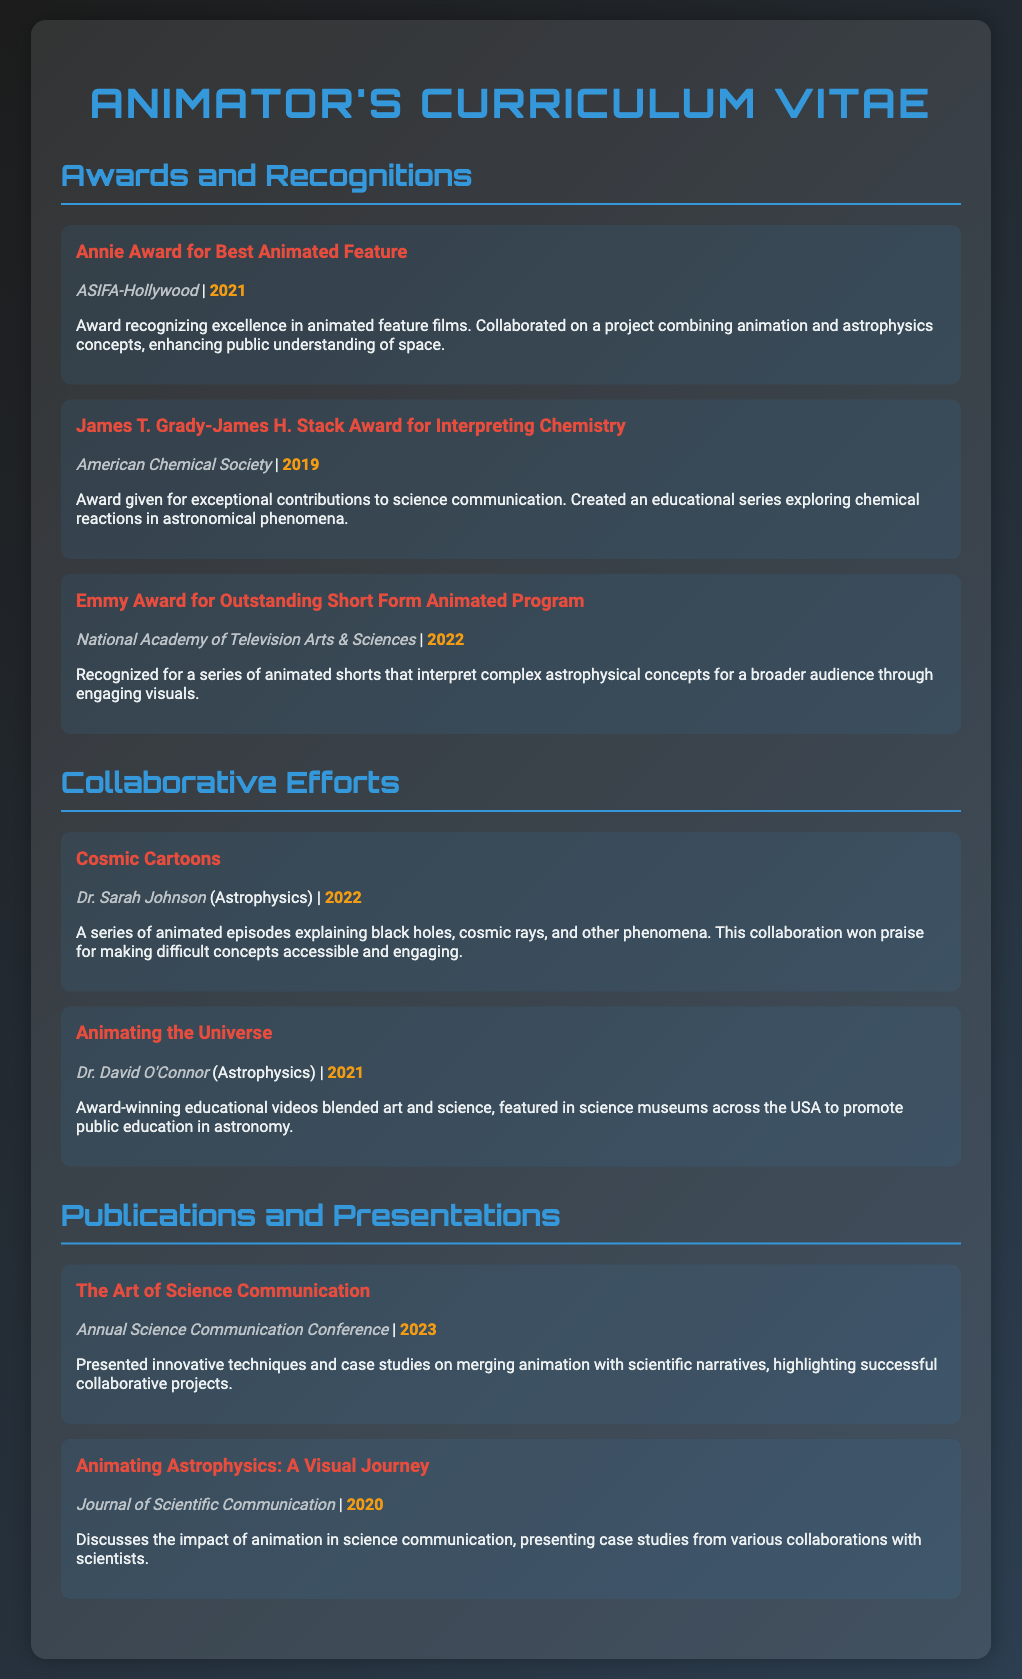What award did you win in 2021? This information can be found in the "Awards and Recognitions" section. The award won in 2021 is the Annie Award for Best Animated Feature.
Answer: Annie Award for Best Animated Feature Who collaborated with you on "Cosmic Cartoons"? The collaborator on the "Cosmic Cartoons" project is mentioned in the "Collaborative Efforts" section. It was Dr. Sarah Johnson.
Answer: Dr. Sarah Johnson What organization awarded the James T. Grady-James H. Stack Award? The awarding organization is noted in the details for the James T. Grady-James H. Stack Award in the "Awards and Recognitions" section. It is the American Chemical Society.
Answer: American Chemical Society Which publication discusses the impact of animation in science communication? This information is located in the "Publications and Presentations" section. The publication that discusses this is "Animating Astrophysics: A Visual Journey."
Answer: Animating Astrophysics: A Visual Journey What year was the Emmy Award for Outstanding Short Form Animated Program awarded? The year of the Emmy award can be found within the "Awards and Recognitions" section of the CV. It was awarded in 2022.
Answer: 2022 What is the main focus of the "Animating the Universe" project? The focus of the "Animating the Universe" project is described in the "Collaborative Efforts" section. It blended art and science as part of educational videos.
Answer: Blended art and science What event did you present at in 2023? The event presented at in 2023 can be found in the "Publications and Presentations" section. It is the Annual Science Communication Conference.
Answer: Annual Science Communication Conference What year was "Animating Astrophysics: A Visual Journey" published? This information is located in the "Publications and Presentations" section. The year of publication is 2020.
Answer: 2020 